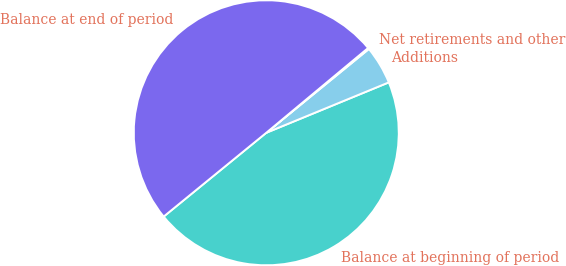Convert chart. <chart><loc_0><loc_0><loc_500><loc_500><pie_chart><fcel>Balance at beginning of period<fcel>Additions<fcel>Net retirements and other<fcel>Balance at end of period<nl><fcel>45.31%<fcel>4.69%<fcel>0.15%<fcel>49.85%<nl></chart> 